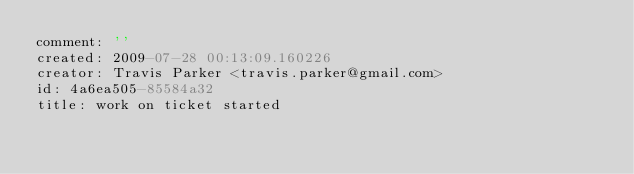<code> <loc_0><loc_0><loc_500><loc_500><_YAML_>comment: ''
created: 2009-07-28 00:13:09.160226
creator: Travis Parker <travis.parker@gmail.com>
id: 4a6ea505-85584a32
title: work on ticket started
</code> 